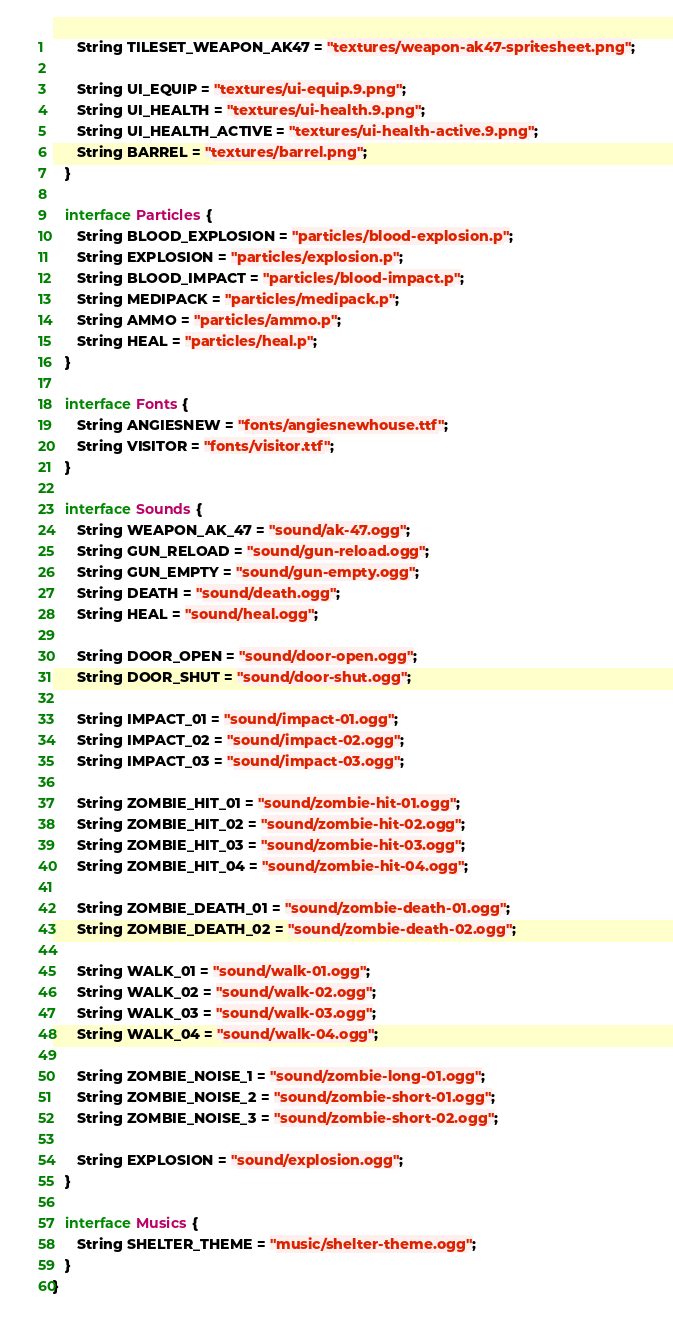<code> <loc_0><loc_0><loc_500><loc_500><_Java_>      String TILESET_WEAPON_AK47 = "textures/weapon-ak47-spritesheet.png";

      String UI_EQUIP = "textures/ui-equip.9.png";
      String UI_HEALTH = "textures/ui-health.9.png";
      String UI_HEALTH_ACTIVE = "textures/ui-health-active.9.png";
      String BARREL = "textures/barrel.png";
   }

   interface Particles {
      String BLOOD_EXPLOSION = "particles/blood-explosion.p";
      String EXPLOSION = "particles/explosion.p";
      String BLOOD_IMPACT = "particles/blood-impact.p";
      String MEDIPACK = "particles/medipack.p";
      String AMMO = "particles/ammo.p";
      String HEAL = "particles/heal.p";
   }

   interface Fonts {
      String ANGIESNEW = "fonts/angiesnewhouse.ttf";
      String VISITOR = "fonts/visitor.ttf";
   }

   interface Sounds {
      String WEAPON_AK_47 = "sound/ak-47.ogg";
      String GUN_RELOAD = "sound/gun-reload.ogg";
      String GUN_EMPTY = "sound/gun-empty.ogg";
      String DEATH = "sound/death.ogg";
      String HEAL = "sound/heal.ogg";

      String DOOR_OPEN = "sound/door-open.ogg";
      String DOOR_SHUT = "sound/door-shut.ogg";

      String IMPACT_01 = "sound/impact-01.ogg";
      String IMPACT_02 = "sound/impact-02.ogg";
      String IMPACT_03 = "sound/impact-03.ogg";

      String ZOMBIE_HIT_01 = "sound/zombie-hit-01.ogg";
      String ZOMBIE_HIT_02 = "sound/zombie-hit-02.ogg";
      String ZOMBIE_HIT_03 = "sound/zombie-hit-03.ogg";
      String ZOMBIE_HIT_04 = "sound/zombie-hit-04.ogg";

      String ZOMBIE_DEATH_01 = "sound/zombie-death-01.ogg";
      String ZOMBIE_DEATH_02 = "sound/zombie-death-02.ogg";

      String WALK_01 = "sound/walk-01.ogg";
      String WALK_02 = "sound/walk-02.ogg";
      String WALK_03 = "sound/walk-03.ogg";
      String WALK_04 = "sound/walk-04.ogg";

      String ZOMBIE_NOISE_1 = "sound/zombie-long-01.ogg";
      String ZOMBIE_NOISE_2 = "sound/zombie-short-01.ogg";
      String ZOMBIE_NOISE_3 = "sound/zombie-short-02.ogg";

      String EXPLOSION = "sound/explosion.ogg";
   }

   interface Musics {
      String SHELTER_THEME = "music/shelter-theme.ogg";
   }
}
</code> 